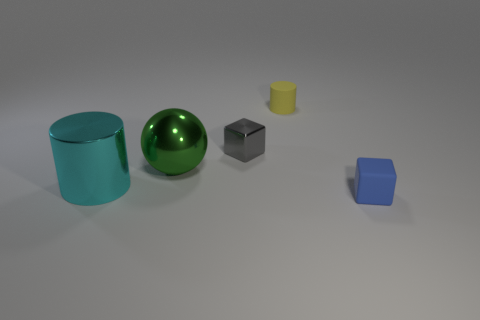Add 5 small blue matte things. How many objects exist? 10 Subtract all spheres. How many objects are left? 4 Add 3 small yellow rubber cylinders. How many small yellow rubber cylinders are left? 4 Add 1 balls. How many balls exist? 2 Subtract 0 green cylinders. How many objects are left? 5 Subtract all gray rubber balls. Subtract all tiny gray things. How many objects are left? 4 